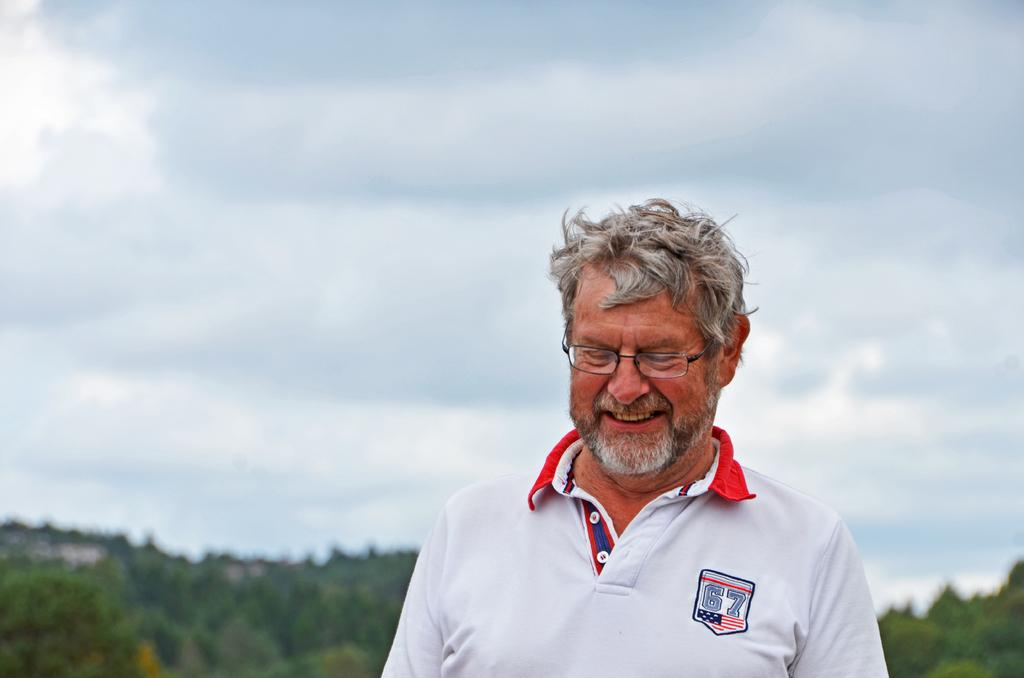Who or what is the main subject of the image? There is a person in the image. What can be observed about the person's appearance? The person is wearing spectacles. What type of natural environment is visible in the background of the image? There are trees in the background of the image. How would you describe the weather based on the sky in the image? The sky is cloudy in the background of the image. What type of soda is being served at the amusement park in the image? There is no amusement park or soda present in the image; it features a person wearing spectacles with trees and a cloudy sky in the background. What type of loaf is being used as a prop in the image? There is no loaf present in the image. 